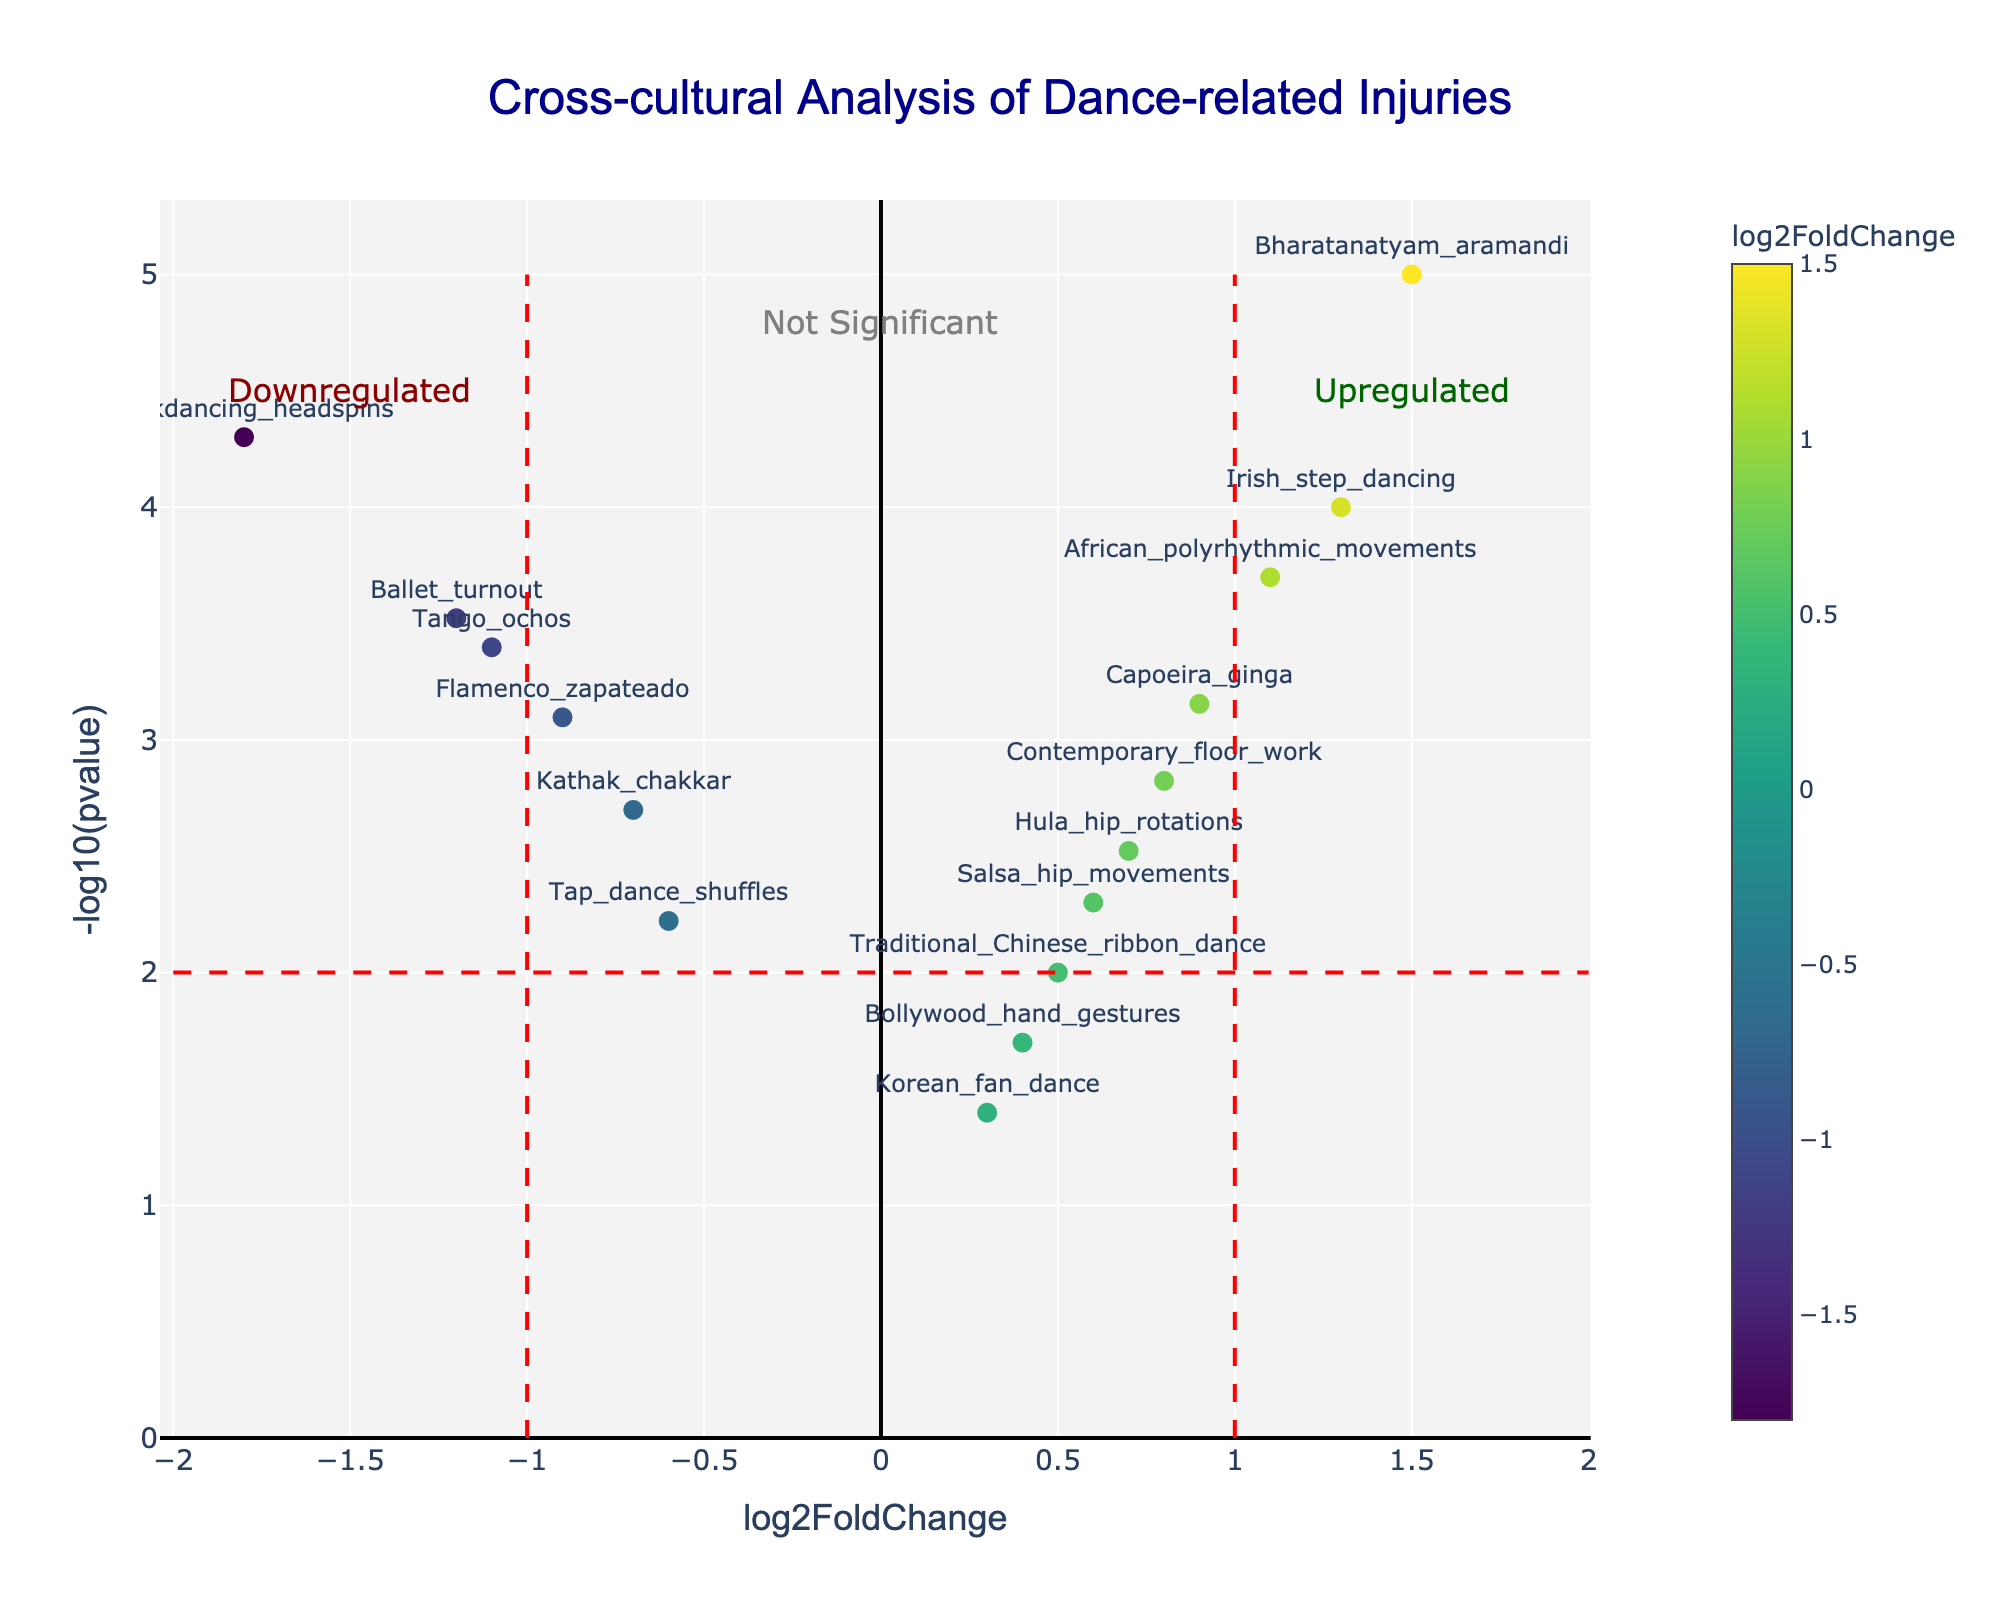What is the title of the plot? The title of the plot is displayed at the top center of the figure. It reads "Cross-cultural Analysis of Dance-related Injuries."
Answer: Cross-cultural Analysis of Dance-related Injuries How many data points indicate upregulated activities? Upregulated activities are indicated by points to the right of the vertical line at log2FoldChange = 1. Counting the data points here results in five such points.
Answer: 5 Which dance activity has the highest -log10(pvalue)? To find this, we look for the data point that reaches the highest y-value (highest -log10(pvalue)). This is Bharatanatyam_aramandi.
Answer: Bharatanatyam_aramandi Which dance activity is the most significantly downregulated? The most significantly downregulated activity will have the lowest log2FoldChange and a high -log10(pvalue). In this case, it is Breakdancing_headspins.
Answer: Breakdancing_headspins List the dance activities that are considered "Not Significant" based on -log10(pvalue). Points below the horizontal significance threshold (y=2) are considered "Not Significant." These points are Bollywood_hand_gestures, Tap_dance_shuffles, Korean_fan_dance, Salsa_hip_movements, and Traditional_Chinese_ribbon_dance.
Answer: Bollywood_hand_gestures, Tap_dance_shuffles, Korean_fan_dance, Salsa_hip_movements, Traditional_Chinese_ribbon_dance Which data point has a log2FoldChange closest to zero? We look for the point near the x-axis, as these represent log2FoldChange close to zero. The data point Korean_fan_dance is closest to zero.
Answer: Korean_fan_dance Compare the significance of Flamenco_zapateado and Irish_step_dancing. Which one is more significant? Significance in this context is assessed with -log10(pvalue), where a higher value means more significance. Comparing Flamenco_zapateado (0.90) with Irish_step_dancing (1.30), Irish_step_dancing is more significant.
Answer: Irish_step_dancing What is the average log2FoldChange of the activities categorized under Downregulated? First, identify the log2FoldChange values of the downregulated activities: Ballet_turnout (-1.2), Flamenco_zapateado (-0.9), Breakdancing_headspins (-1.8), Tango_ochos (-1.1), Kathak_chakkar (-0.7), Tap_dance_shuffles (-0.6). Sum these values: -1.2 + (-0.9) + (-1.8) + (-1.1) + (-0.7) + (-0.6) = -6.3. Divide by the number of points (6), so the average is -6.3 / 6 = -1.05.
Answer: -1.05 